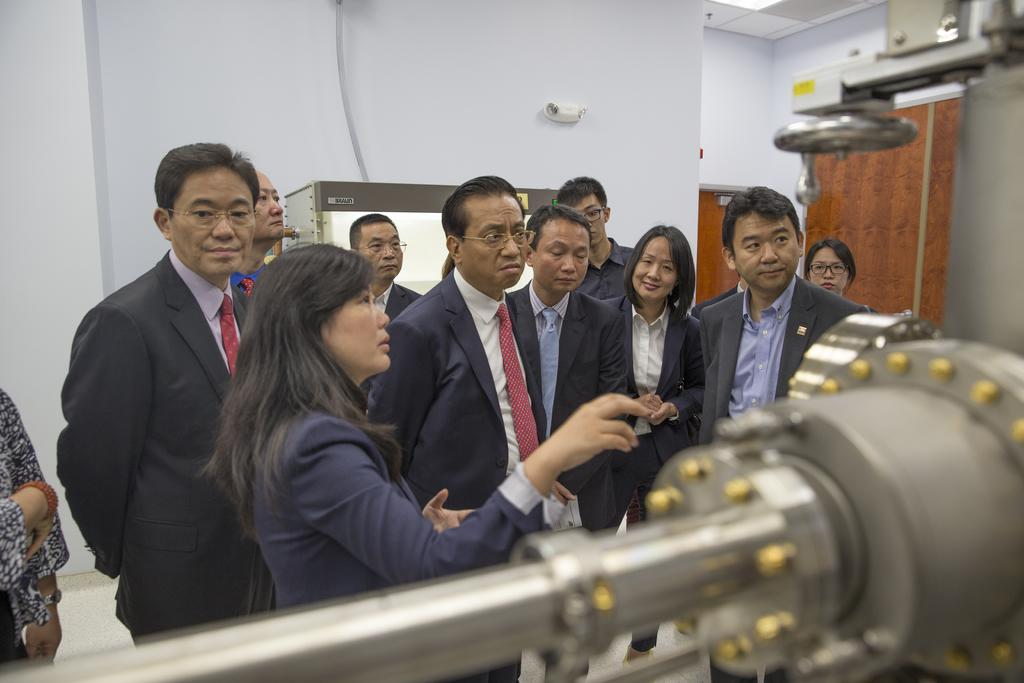What are the people in the image doing? There is a group of people standing in the image. What else can be seen in the image besides the people? There is a machine, bolts, a wooden door, and a wall visible in the image. Can you describe the machine in the image? The machine is silver in color. What is the wooden door attached to in the image? The wooden door is attached to a wall in the image. What type of advertisement is displayed on the scarecrow in the image? There is no scarecrow present in the image, so no advertisement can be observed. What type of building is shown in the image? The image does not show a building; it features a group of people, a machine, bolts, a wooden door, and a wall. 